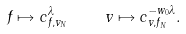<formula> <loc_0><loc_0><loc_500><loc_500>f \mapsto c _ { f , v _ { N } } ^ { \lambda } \quad v \mapsto c ^ { - w _ { 0 } \lambda } _ { v , f _ { N } } .</formula> 